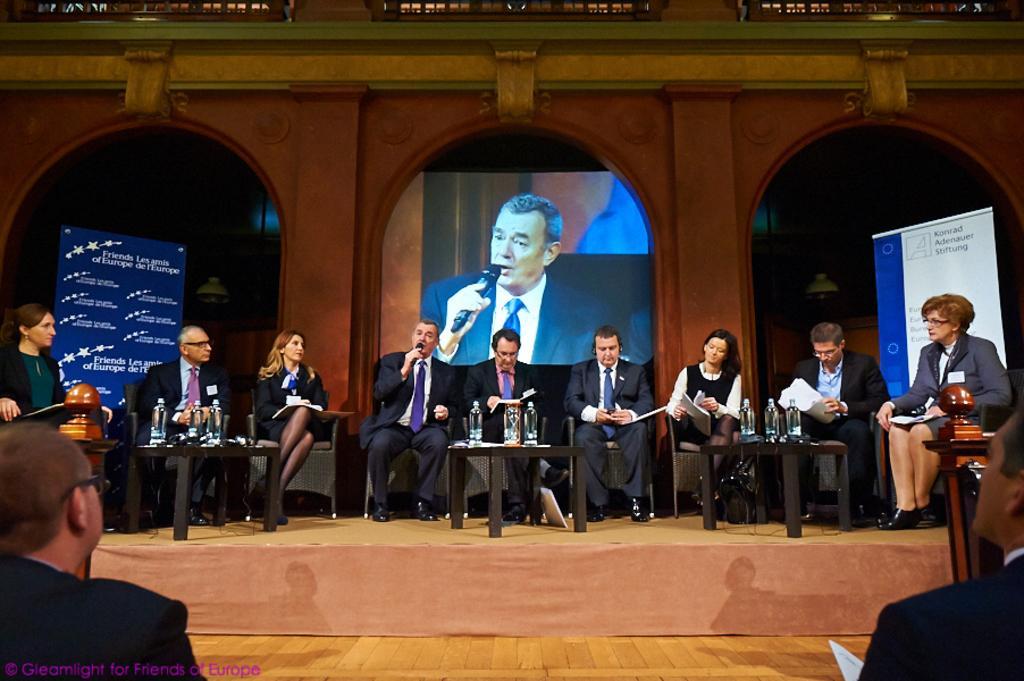Can you describe this image briefly? In this image, we can see a group of people. Few are on the stage. They are sitting on the chairs. At the bottom, there is wooden floor. Here there are few tables, bottles and objects are placed on it. In the middle of the image, a person is holding a microphone. Background we can see pillars, lights, banners, screen. Top of the image, there is a railings. 